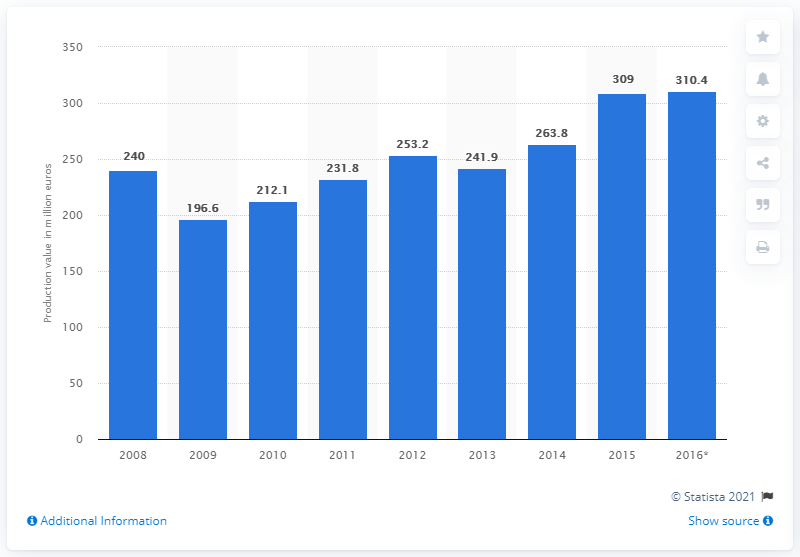Draw attention to some important aspects in this diagram. In 2015, the production value of the Estonian textile manufacturing sector was 310.4 million euros. 